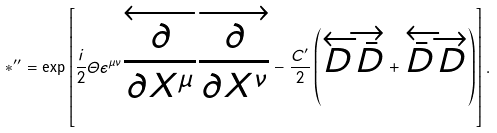<formula> <loc_0><loc_0><loc_500><loc_500>\ast ^ { \prime \prime } = \exp \left [ \frac { i } { 2 } \varTheta \epsilon ^ { \mu \nu } \overleftarrow { \frac { \partial } { \partial X ^ { \mu } } } \overrightarrow { \frac { \partial } { \partial X ^ { \nu } } } - \frac { C ^ { \prime } } { 2 } \left ( \overleftarrow { D } \overrightarrow { \bar { D } } + \overleftarrow { \bar { D } } \overrightarrow { D } \right ) \right ] .</formula> 